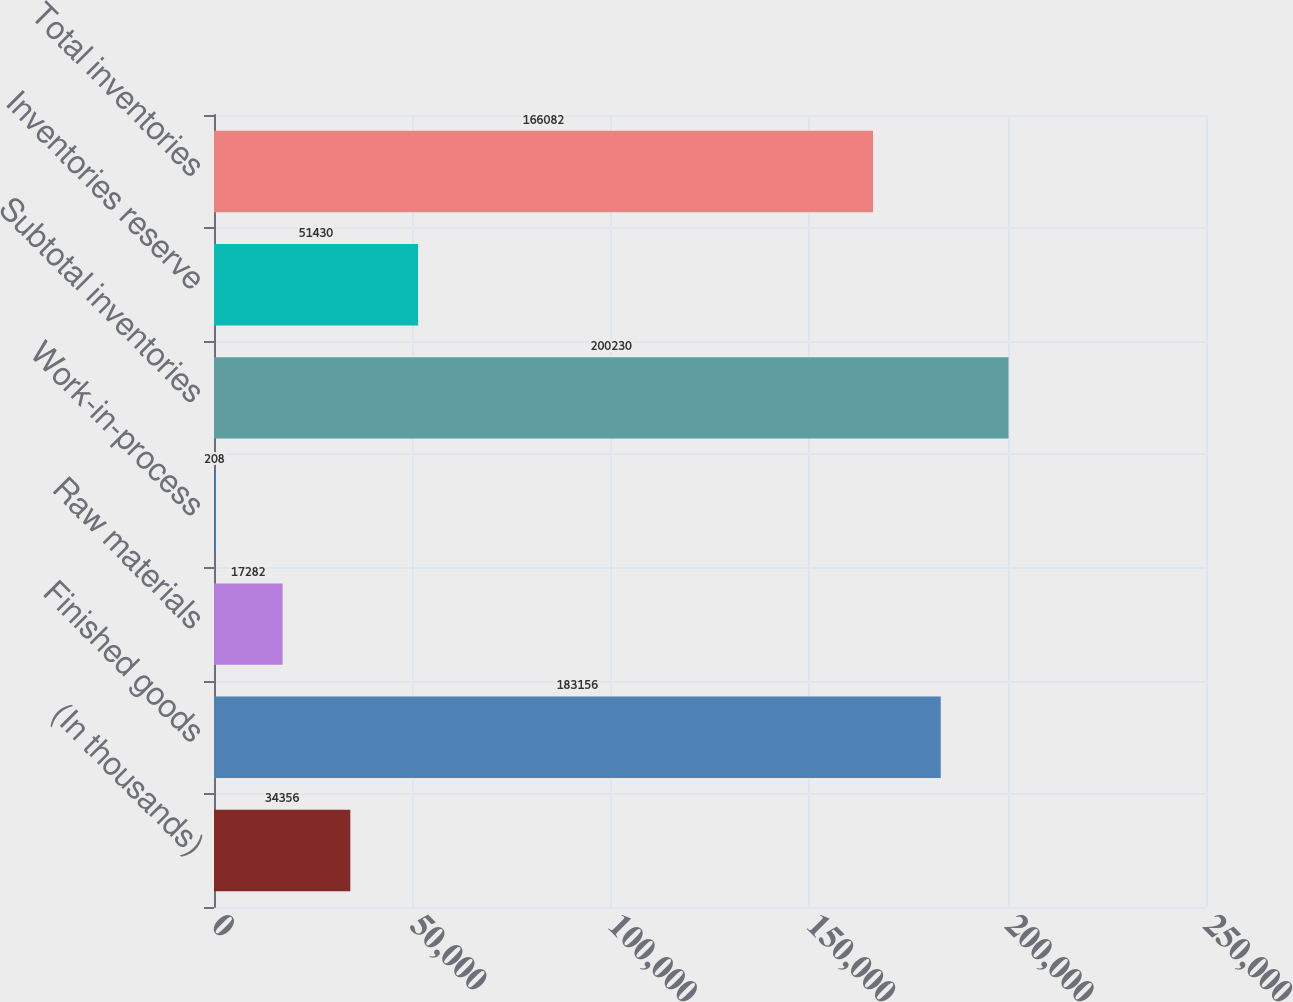Convert chart to OTSL. <chart><loc_0><loc_0><loc_500><loc_500><bar_chart><fcel>(In thousands)<fcel>Finished goods<fcel>Raw materials<fcel>Work-in-process<fcel>Subtotal inventories<fcel>Inventories reserve<fcel>Total inventories<nl><fcel>34356<fcel>183156<fcel>17282<fcel>208<fcel>200230<fcel>51430<fcel>166082<nl></chart> 